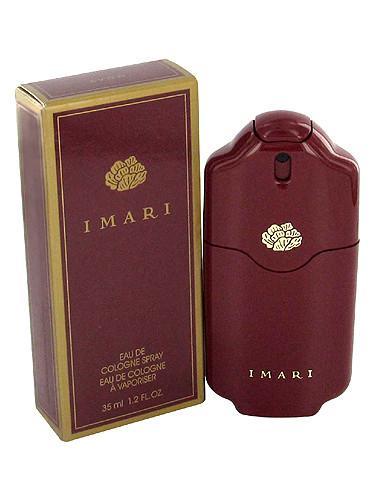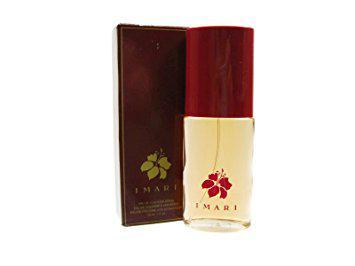The first image is the image on the left, the second image is the image on the right. Evaluate the accuracy of this statement regarding the images: "The image on the left contains only one bottle of fragrance, and its box.". Is it true? Answer yes or no. Yes. 